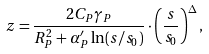<formula> <loc_0><loc_0><loc_500><loc_500>z = \frac { 2 C _ { P } \gamma _ { P } } { R ^ { 2 } _ { P } + \alpha ^ { \prime } _ { P } \ln ( s / s _ { 0 } ) } \cdot \left ( \frac { s } { s _ { 0 } } \right ) ^ { \Delta } ,</formula> 